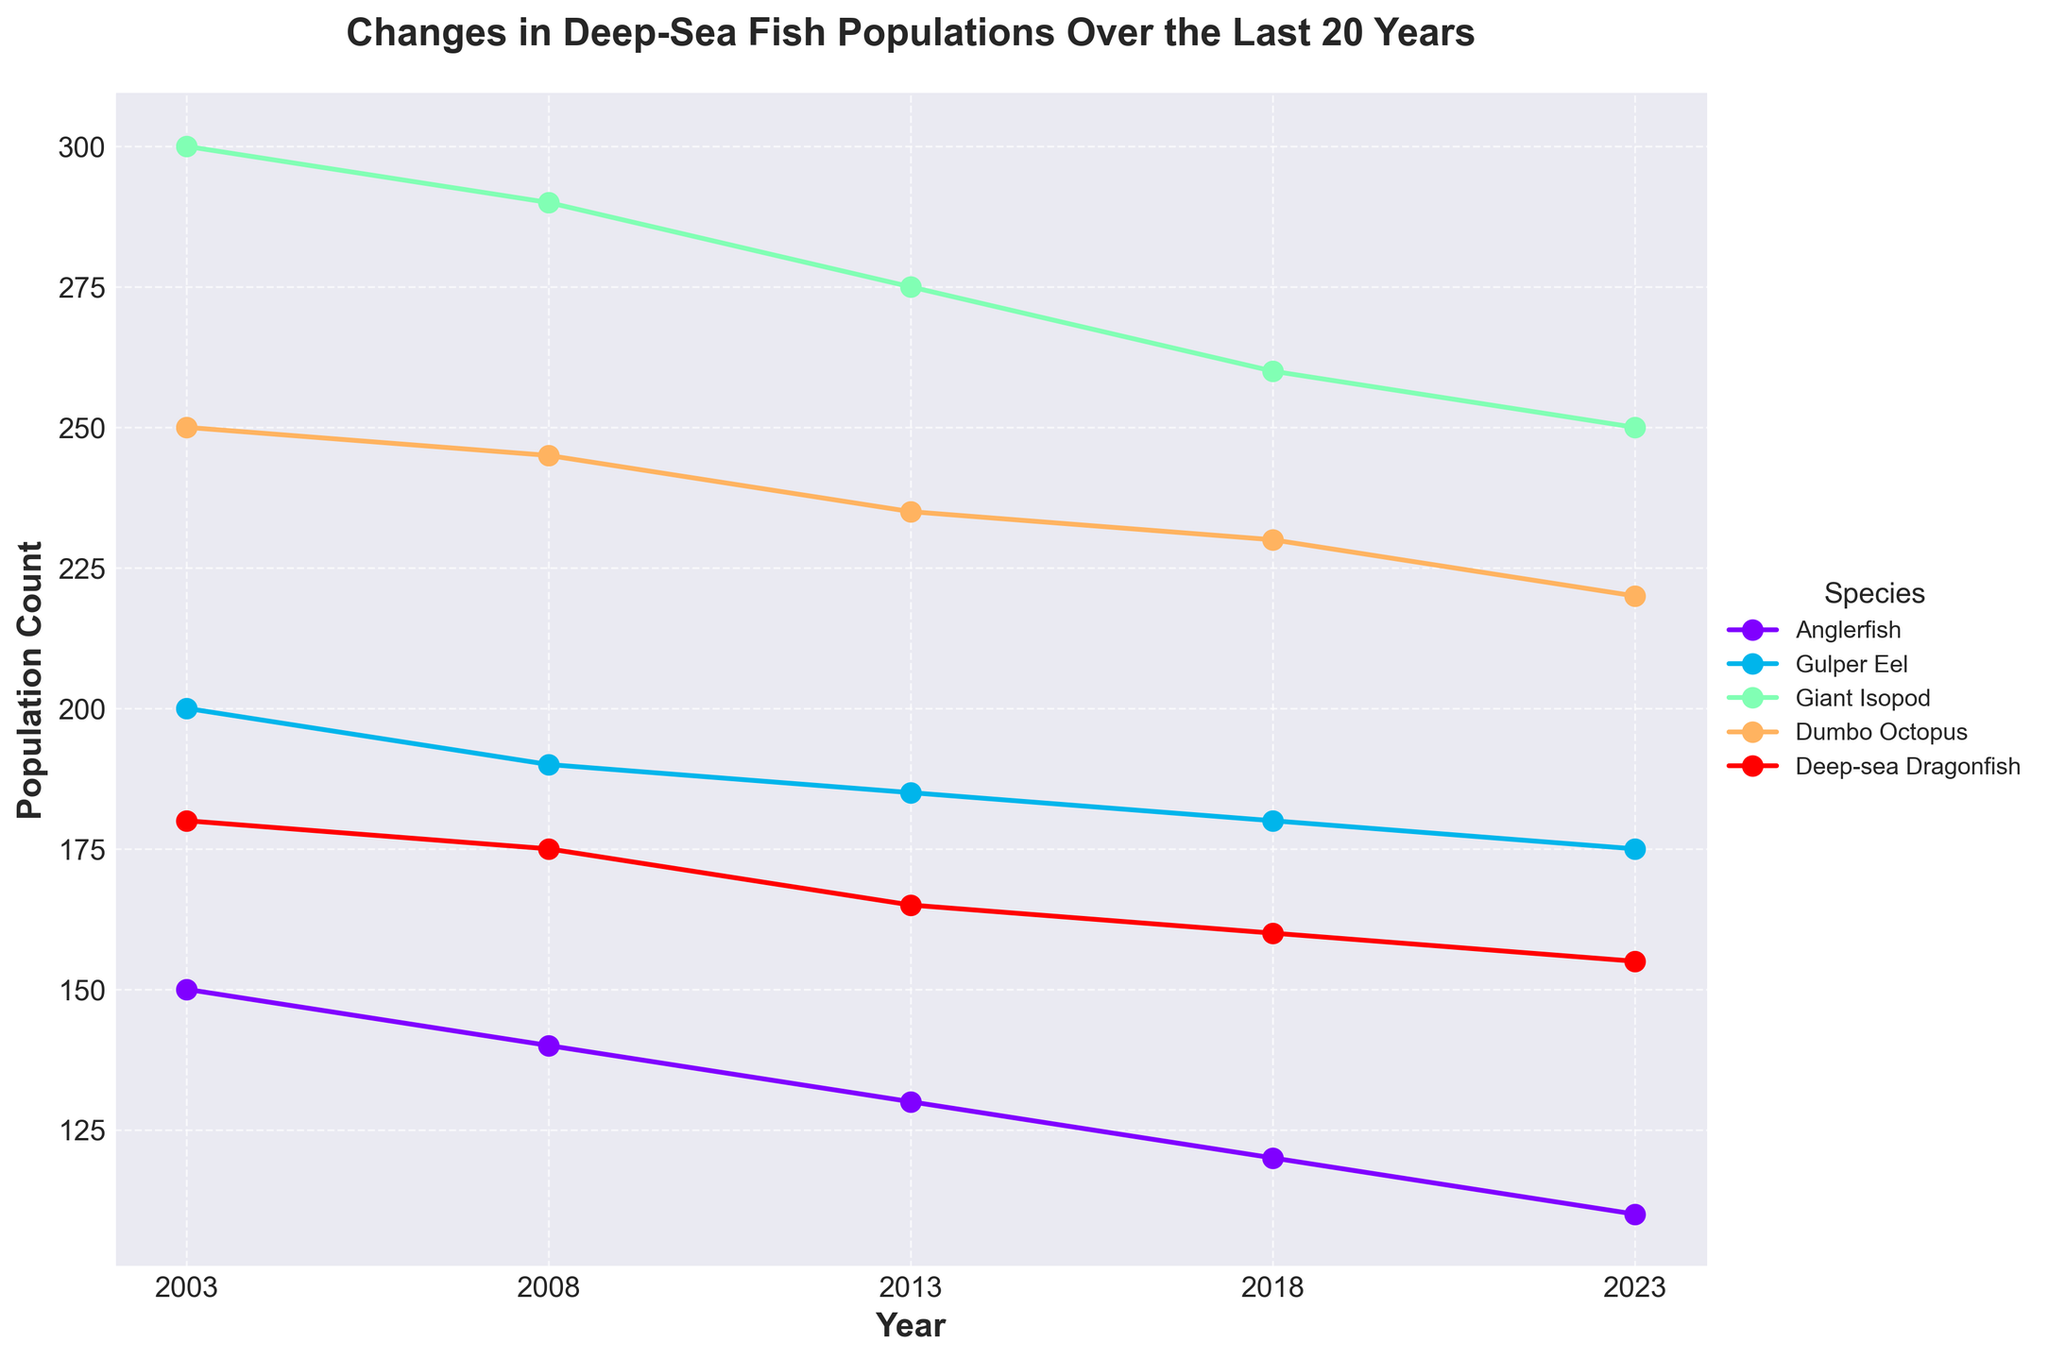What is the title of the figure? The title of the figure is usually found at the top of the plot. It describes the main subject or focus of the figure. Here it is clearly written at the top.
Answer: Changes in Deep-Sea Fish Populations Over the Last 20 Years How many species are shown in the plot? The different species are represented by different colored lines, and the legend to the right side of the plot lists all the species. Count the number of species listed in the legend.
Answer: 5 What year is the data first available for all species? Follow each line from the leftmost point to see where they all start. Each line represents a species, and they all converge at the first year in the x-axis.
Answer: 2003 Which species had the highest population count in 2023? Look at the rightmost points of each line on the graph for the year 2023 and compare the heights. The species with the highest point has the highest population count.
Answer: Giant Isopod How did the population of the Anglerfish change from 2003 to 2023? Track the line for Anglerfish from 2003 to 2023 and observe the trend in height. The difference between the starting and ending points provides the answer.
Answer: Decreased by 40 What is the general trend for the Gulper Eel population over the 20-year period? Observe the line representing the Gulper Eel. Follow its trajectory from 2003 to 2023 to determine if it generally goes up, down, or remains constant.
Answer: Decreasing Which species shows the least change in population over the observed years? Compare the range of fluctuations in each species' line. The line with the smallest vertical movement indicates the least change.
Answer: Dumbo Octopus Between which consecutive years is the largest drop in Deep-sea Dragonfish population observed? Follow the line for Deep-sea Dragonfish and identify the consecutive years where the drop (downward movement) is the largest.
Answer: 2003 to 2008 What is the approximate population count of Giant Isopods in 2018? Follow the line for Giant Isopods to the point corresponding to the year 2018 and read the y-axis value at this point.
Answer: 260 Did the population of the Deep-sea Dragonfish increase or decrease between 2008 and 2013? Follow the line for Deep-sea Dragonfish between 2008 and 2013. If the line goes up, it increased; if it goes down, it decreased.
Answer: Decrease 